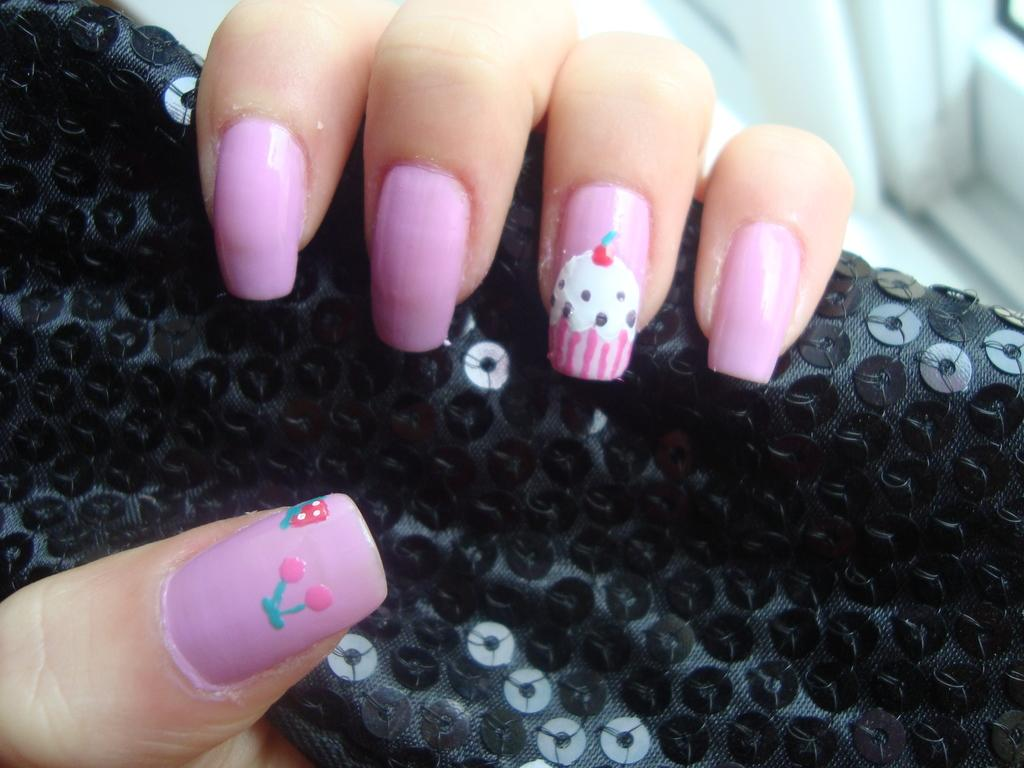What can be seen in the image related to a person's hand? There are fingers of a person in the image. What is the person holding in the image? The fingers are holding a black object. Can you describe the appearance of the person's nails in the image? Nail polish is visible on the nails. What type of lipstick is being applied on the stage in the image? There is no lipstick or stage present in the image; it only shows a person's fingers holding a black object with nail polish on the nails. 